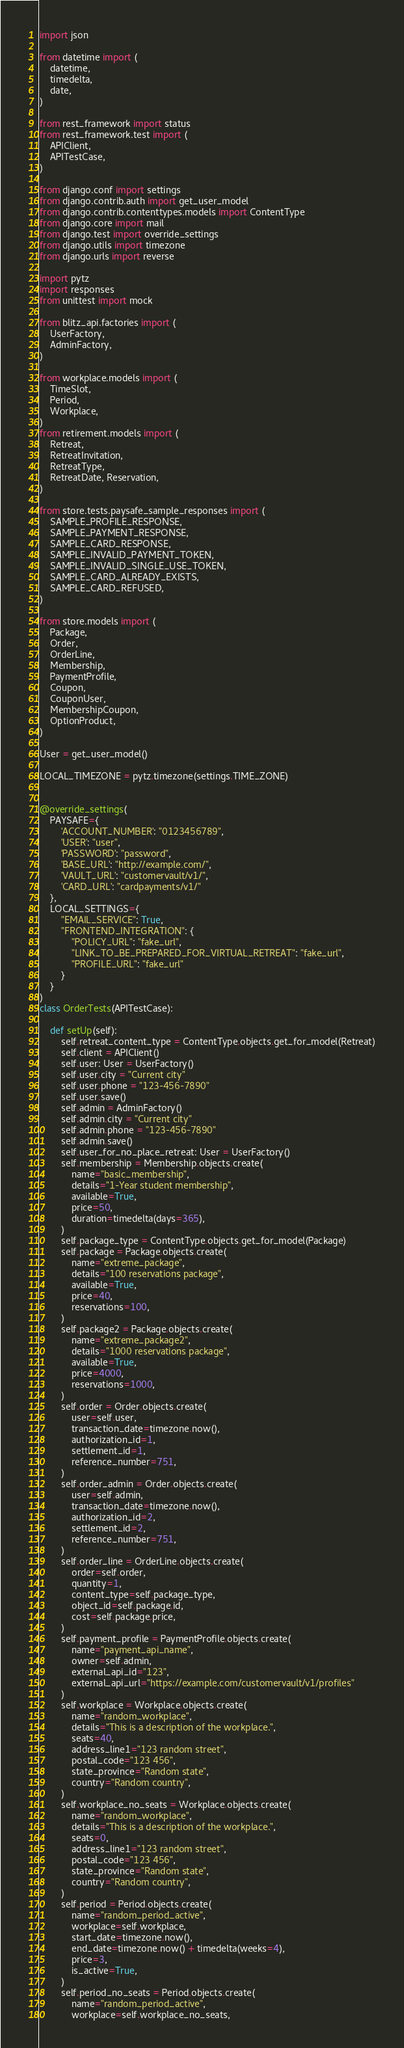<code> <loc_0><loc_0><loc_500><loc_500><_Python_>import json

from datetime import (
    datetime,
    timedelta,
    date,
)

from rest_framework import status
from rest_framework.test import (
    APIClient,
    APITestCase,
)

from django.conf import settings
from django.contrib.auth import get_user_model
from django.contrib.contenttypes.models import ContentType
from django.core import mail
from django.test import override_settings
from django.utils import timezone
from django.urls import reverse

import pytz
import responses
from unittest import mock

from blitz_api.factories import (
    UserFactory,
    AdminFactory,
)

from workplace.models import (
    TimeSlot,
    Period,
    Workplace,
)
from retirement.models import (
    Retreat,
    RetreatInvitation,
    RetreatType,
    RetreatDate, Reservation,
)

from store.tests.paysafe_sample_responses import (
    SAMPLE_PROFILE_RESPONSE,
    SAMPLE_PAYMENT_RESPONSE,
    SAMPLE_CARD_RESPONSE,
    SAMPLE_INVALID_PAYMENT_TOKEN,
    SAMPLE_INVALID_SINGLE_USE_TOKEN,
    SAMPLE_CARD_ALREADY_EXISTS,
    SAMPLE_CARD_REFUSED,
)

from store.models import (
    Package,
    Order,
    OrderLine,
    Membership,
    PaymentProfile,
    Coupon,
    CouponUser,
    MembershipCoupon,
    OptionProduct,
)

User = get_user_model()

LOCAL_TIMEZONE = pytz.timezone(settings.TIME_ZONE)


@override_settings(
    PAYSAFE={
        'ACCOUNT_NUMBER': "0123456789",
        'USER': "user",
        'PASSWORD': "password",
        'BASE_URL': "http://example.com/",
        'VAULT_URL': "customervault/v1/",
        'CARD_URL': "cardpayments/v1/"
    },
    LOCAL_SETTINGS={
        "EMAIL_SERVICE": True,
        "FRONTEND_INTEGRATION": {
            "POLICY_URL": "fake_url",
            "LINK_TO_BE_PREPARED_FOR_VIRTUAL_RETREAT": "fake_url",
            "PROFILE_URL": "fake_url"
        }
    }
)
class OrderTests(APITestCase):

    def setUp(self):
        self.retreat_content_type = ContentType.objects.get_for_model(Retreat)
        self.client = APIClient()
        self.user: User = UserFactory()
        self.user.city = "Current city"
        self.user.phone = "123-456-7890"
        self.user.save()
        self.admin = AdminFactory()
        self.admin.city = "Current city"
        self.admin.phone = "123-456-7890"
        self.admin.save()
        self.user_for_no_place_retreat: User = UserFactory()
        self.membership = Membership.objects.create(
            name="basic_membership",
            details="1-Year student membership",
            available=True,
            price=50,
            duration=timedelta(days=365),
        )
        self.package_type = ContentType.objects.get_for_model(Package)
        self.package = Package.objects.create(
            name="extreme_package",
            details="100 reservations package",
            available=True,
            price=40,
            reservations=100,
        )
        self.package2 = Package.objects.create(
            name="extreme_package2",
            details="1000 reservations package",
            available=True,
            price=4000,
            reservations=1000,
        )
        self.order = Order.objects.create(
            user=self.user,
            transaction_date=timezone.now(),
            authorization_id=1,
            settlement_id=1,
            reference_number=751,
        )
        self.order_admin = Order.objects.create(
            user=self.admin,
            transaction_date=timezone.now(),
            authorization_id=2,
            settlement_id=2,
            reference_number=751,
        )
        self.order_line = OrderLine.objects.create(
            order=self.order,
            quantity=1,
            content_type=self.package_type,
            object_id=self.package.id,
            cost=self.package.price,
        )
        self.payment_profile = PaymentProfile.objects.create(
            name="payment_api_name",
            owner=self.admin,
            external_api_id="123",
            external_api_url="https://example.com/customervault/v1/profiles"
        )
        self.workplace = Workplace.objects.create(
            name="random_workplace",
            details="This is a description of the workplace.",
            seats=40,
            address_line1="123 random street",
            postal_code="123 456",
            state_province="Random state",
            country="Random country",
        )
        self.workplace_no_seats = Workplace.objects.create(
            name="random_workplace",
            details="This is a description of the workplace.",
            seats=0,
            address_line1="123 random street",
            postal_code="123 456",
            state_province="Random state",
            country="Random country",
        )
        self.period = Period.objects.create(
            name="random_period_active",
            workplace=self.workplace,
            start_date=timezone.now(),
            end_date=timezone.now() + timedelta(weeks=4),
            price=3,
            is_active=True,
        )
        self.period_no_seats = Period.objects.create(
            name="random_period_active",
            workplace=self.workplace_no_seats,</code> 